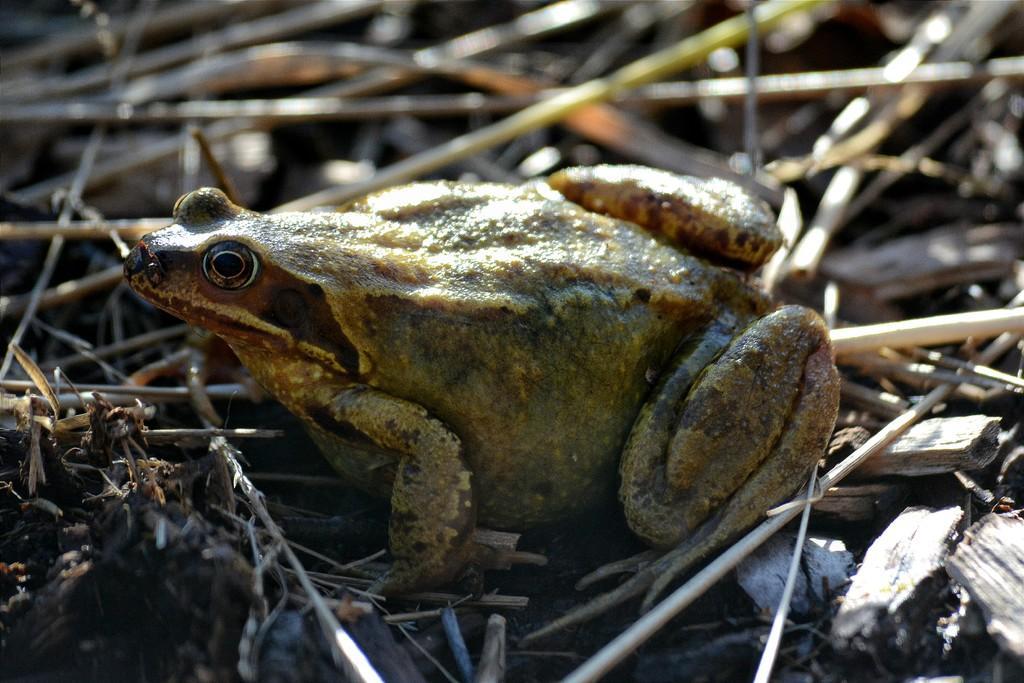How would you summarize this image in a sentence or two? In this image, we can see a frog on sticks. In the background, image is blurred. 